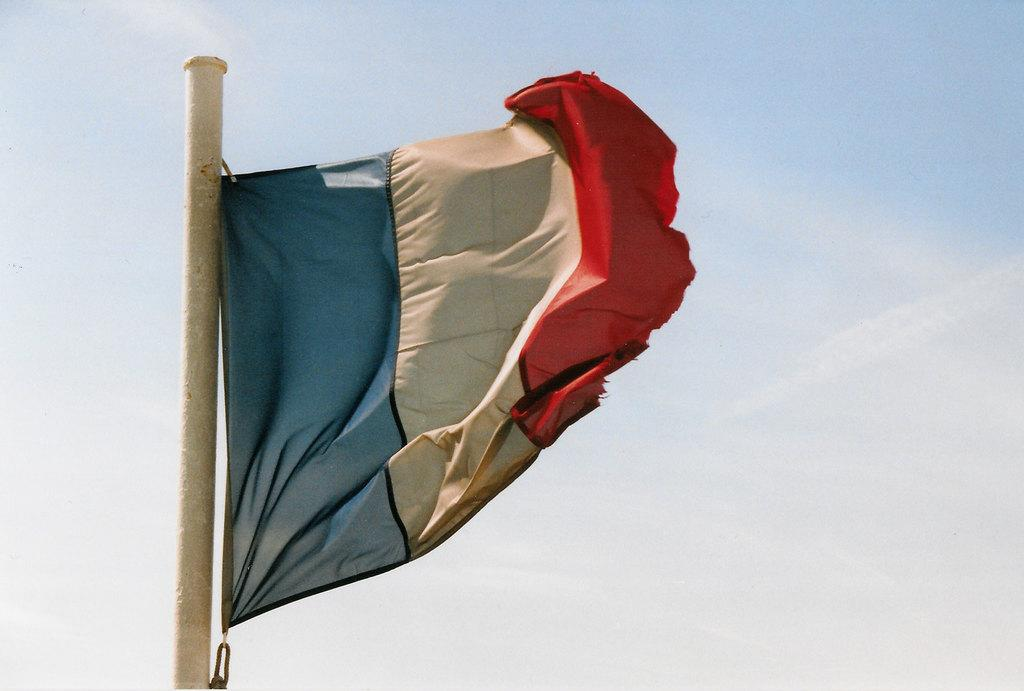What is located on the left side of the image? There is a flag on the left side of the image. What can be seen in the background of the image? The sky is visible in the background of the image. What type of pencil is being used to draw on the roof in the image? There is no pencil or roof present in the image; it only features a flag and the sky in the background. 